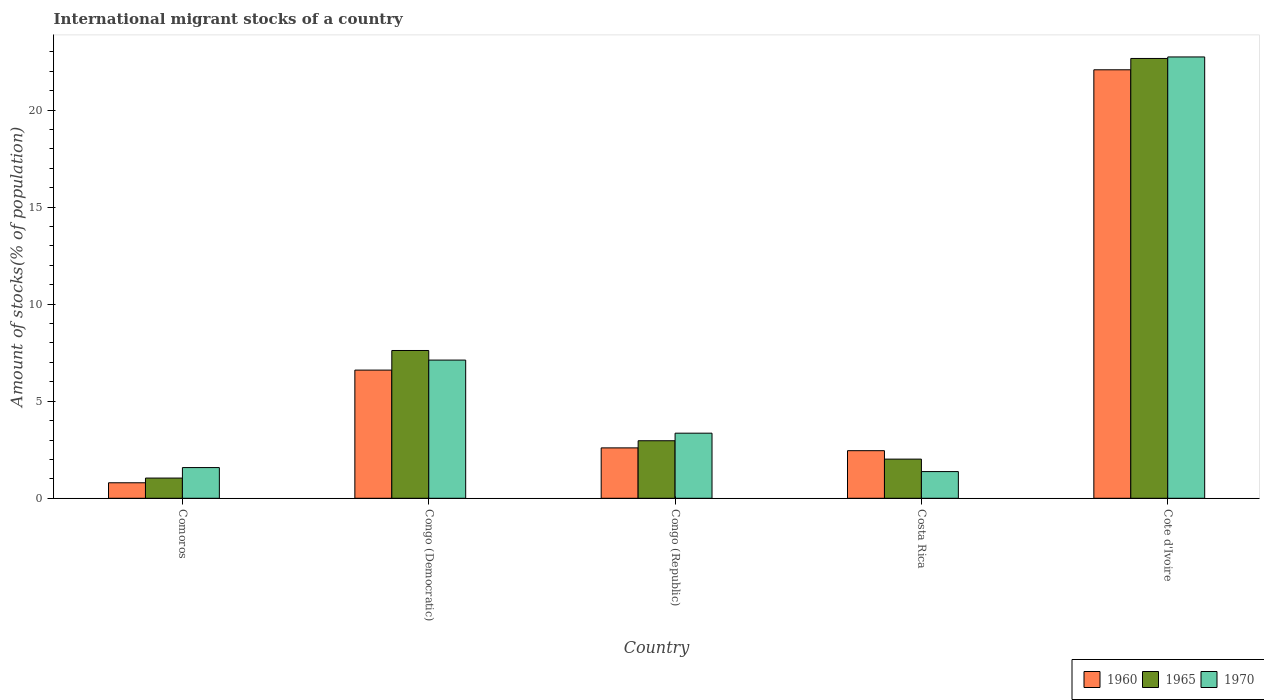How many different coloured bars are there?
Your answer should be compact. 3. Are the number of bars per tick equal to the number of legend labels?
Offer a very short reply. Yes. How many bars are there on the 2nd tick from the left?
Provide a succinct answer. 3. How many bars are there on the 2nd tick from the right?
Offer a terse response. 3. What is the label of the 2nd group of bars from the left?
Your answer should be compact. Congo (Democratic). What is the amount of stocks in in 1965 in Cote d'Ivoire?
Keep it short and to the point. 22.66. Across all countries, what is the maximum amount of stocks in in 1965?
Provide a succinct answer. 22.66. Across all countries, what is the minimum amount of stocks in in 1960?
Give a very brief answer. 0.8. In which country was the amount of stocks in in 1970 maximum?
Your answer should be very brief. Cote d'Ivoire. In which country was the amount of stocks in in 1970 minimum?
Ensure brevity in your answer.  Costa Rica. What is the total amount of stocks in in 1970 in the graph?
Your answer should be compact. 36.17. What is the difference between the amount of stocks in in 1965 in Congo (Democratic) and that in Cote d'Ivoire?
Your response must be concise. -15.04. What is the difference between the amount of stocks in in 1965 in Costa Rica and the amount of stocks in in 1960 in Cote d'Ivoire?
Make the answer very short. -20.06. What is the average amount of stocks in in 1970 per country?
Provide a short and direct response. 7.23. What is the difference between the amount of stocks in of/in 1970 and amount of stocks in of/in 1965 in Congo (Republic)?
Give a very brief answer. 0.39. In how many countries, is the amount of stocks in in 1960 greater than 16 %?
Offer a very short reply. 1. What is the ratio of the amount of stocks in in 1960 in Comoros to that in Congo (Republic)?
Keep it short and to the point. 0.31. Is the amount of stocks in in 1970 in Comoros less than that in Congo (Democratic)?
Keep it short and to the point. Yes. Is the difference between the amount of stocks in in 1970 in Comoros and Cote d'Ivoire greater than the difference between the amount of stocks in in 1965 in Comoros and Cote d'Ivoire?
Make the answer very short. Yes. What is the difference between the highest and the second highest amount of stocks in in 1970?
Provide a short and direct response. -19.38. What is the difference between the highest and the lowest amount of stocks in in 1970?
Make the answer very short. 21.36. In how many countries, is the amount of stocks in in 1970 greater than the average amount of stocks in in 1970 taken over all countries?
Make the answer very short. 1. Is the sum of the amount of stocks in in 1960 in Comoros and Congo (Republic) greater than the maximum amount of stocks in in 1970 across all countries?
Keep it short and to the point. No. How many countries are there in the graph?
Give a very brief answer. 5. What is the difference between two consecutive major ticks on the Y-axis?
Make the answer very short. 5. Are the values on the major ticks of Y-axis written in scientific E-notation?
Keep it short and to the point. No. Does the graph contain any zero values?
Offer a terse response. No. Where does the legend appear in the graph?
Your answer should be compact. Bottom right. How many legend labels are there?
Your answer should be very brief. 3. How are the legend labels stacked?
Offer a terse response. Horizontal. What is the title of the graph?
Keep it short and to the point. International migrant stocks of a country. What is the label or title of the X-axis?
Your response must be concise. Country. What is the label or title of the Y-axis?
Your response must be concise. Amount of stocks(% of population). What is the Amount of stocks(% of population) in 1960 in Comoros?
Your response must be concise. 0.8. What is the Amount of stocks(% of population) in 1965 in Comoros?
Your response must be concise. 1.04. What is the Amount of stocks(% of population) in 1970 in Comoros?
Give a very brief answer. 1.58. What is the Amount of stocks(% of population) of 1960 in Congo (Democratic)?
Give a very brief answer. 6.6. What is the Amount of stocks(% of population) in 1965 in Congo (Democratic)?
Make the answer very short. 7.61. What is the Amount of stocks(% of population) of 1970 in Congo (Democratic)?
Your response must be concise. 7.12. What is the Amount of stocks(% of population) in 1960 in Congo (Republic)?
Your answer should be very brief. 2.6. What is the Amount of stocks(% of population) in 1965 in Congo (Republic)?
Provide a short and direct response. 2.96. What is the Amount of stocks(% of population) of 1970 in Congo (Republic)?
Your answer should be compact. 3.35. What is the Amount of stocks(% of population) of 1960 in Costa Rica?
Make the answer very short. 2.45. What is the Amount of stocks(% of population) in 1965 in Costa Rica?
Ensure brevity in your answer.  2.02. What is the Amount of stocks(% of population) of 1970 in Costa Rica?
Provide a short and direct response. 1.38. What is the Amount of stocks(% of population) of 1960 in Cote d'Ivoire?
Give a very brief answer. 22.07. What is the Amount of stocks(% of population) of 1965 in Cote d'Ivoire?
Offer a terse response. 22.66. What is the Amount of stocks(% of population) in 1970 in Cote d'Ivoire?
Your answer should be compact. 22.74. Across all countries, what is the maximum Amount of stocks(% of population) in 1960?
Keep it short and to the point. 22.07. Across all countries, what is the maximum Amount of stocks(% of population) of 1965?
Provide a short and direct response. 22.66. Across all countries, what is the maximum Amount of stocks(% of population) in 1970?
Offer a terse response. 22.74. Across all countries, what is the minimum Amount of stocks(% of population) of 1960?
Give a very brief answer. 0.8. Across all countries, what is the minimum Amount of stocks(% of population) in 1965?
Your response must be concise. 1.04. Across all countries, what is the minimum Amount of stocks(% of population) in 1970?
Provide a short and direct response. 1.38. What is the total Amount of stocks(% of population) in 1960 in the graph?
Make the answer very short. 34.53. What is the total Amount of stocks(% of population) in 1965 in the graph?
Your response must be concise. 36.29. What is the total Amount of stocks(% of population) in 1970 in the graph?
Make the answer very short. 36.17. What is the difference between the Amount of stocks(% of population) in 1960 in Comoros and that in Congo (Democratic)?
Your answer should be compact. -5.81. What is the difference between the Amount of stocks(% of population) of 1965 in Comoros and that in Congo (Democratic)?
Provide a succinct answer. -6.57. What is the difference between the Amount of stocks(% of population) of 1970 in Comoros and that in Congo (Democratic)?
Offer a very short reply. -5.54. What is the difference between the Amount of stocks(% of population) of 1960 in Comoros and that in Congo (Republic)?
Your answer should be compact. -1.8. What is the difference between the Amount of stocks(% of population) of 1965 in Comoros and that in Congo (Republic)?
Provide a succinct answer. -1.92. What is the difference between the Amount of stocks(% of population) of 1970 in Comoros and that in Congo (Republic)?
Provide a short and direct response. -1.77. What is the difference between the Amount of stocks(% of population) of 1960 in Comoros and that in Costa Rica?
Your response must be concise. -1.65. What is the difference between the Amount of stocks(% of population) of 1965 in Comoros and that in Costa Rica?
Ensure brevity in your answer.  -0.98. What is the difference between the Amount of stocks(% of population) in 1970 in Comoros and that in Costa Rica?
Offer a terse response. 0.21. What is the difference between the Amount of stocks(% of population) of 1960 in Comoros and that in Cote d'Ivoire?
Offer a very short reply. -21.28. What is the difference between the Amount of stocks(% of population) in 1965 in Comoros and that in Cote d'Ivoire?
Ensure brevity in your answer.  -21.62. What is the difference between the Amount of stocks(% of population) in 1970 in Comoros and that in Cote d'Ivoire?
Make the answer very short. -21.15. What is the difference between the Amount of stocks(% of population) in 1960 in Congo (Democratic) and that in Congo (Republic)?
Make the answer very short. 4.01. What is the difference between the Amount of stocks(% of population) of 1965 in Congo (Democratic) and that in Congo (Republic)?
Offer a very short reply. 4.65. What is the difference between the Amount of stocks(% of population) in 1970 in Congo (Democratic) and that in Congo (Republic)?
Ensure brevity in your answer.  3.77. What is the difference between the Amount of stocks(% of population) of 1960 in Congo (Democratic) and that in Costa Rica?
Your answer should be compact. 4.15. What is the difference between the Amount of stocks(% of population) of 1965 in Congo (Democratic) and that in Costa Rica?
Provide a succinct answer. 5.6. What is the difference between the Amount of stocks(% of population) of 1970 in Congo (Democratic) and that in Costa Rica?
Offer a terse response. 5.74. What is the difference between the Amount of stocks(% of population) in 1960 in Congo (Democratic) and that in Cote d'Ivoire?
Offer a terse response. -15.47. What is the difference between the Amount of stocks(% of population) of 1965 in Congo (Democratic) and that in Cote d'Ivoire?
Make the answer very short. -15.04. What is the difference between the Amount of stocks(% of population) in 1970 in Congo (Democratic) and that in Cote d'Ivoire?
Your answer should be compact. -15.62. What is the difference between the Amount of stocks(% of population) in 1960 in Congo (Republic) and that in Costa Rica?
Offer a terse response. 0.14. What is the difference between the Amount of stocks(% of population) in 1965 in Congo (Republic) and that in Costa Rica?
Keep it short and to the point. 0.95. What is the difference between the Amount of stocks(% of population) of 1970 in Congo (Republic) and that in Costa Rica?
Provide a short and direct response. 1.98. What is the difference between the Amount of stocks(% of population) of 1960 in Congo (Republic) and that in Cote d'Ivoire?
Provide a short and direct response. -19.48. What is the difference between the Amount of stocks(% of population) of 1965 in Congo (Republic) and that in Cote d'Ivoire?
Ensure brevity in your answer.  -19.69. What is the difference between the Amount of stocks(% of population) in 1970 in Congo (Republic) and that in Cote d'Ivoire?
Your answer should be very brief. -19.38. What is the difference between the Amount of stocks(% of population) in 1960 in Costa Rica and that in Cote d'Ivoire?
Give a very brief answer. -19.62. What is the difference between the Amount of stocks(% of population) in 1965 in Costa Rica and that in Cote d'Ivoire?
Your answer should be compact. -20.64. What is the difference between the Amount of stocks(% of population) of 1970 in Costa Rica and that in Cote d'Ivoire?
Ensure brevity in your answer.  -21.36. What is the difference between the Amount of stocks(% of population) in 1960 in Comoros and the Amount of stocks(% of population) in 1965 in Congo (Democratic)?
Keep it short and to the point. -6.82. What is the difference between the Amount of stocks(% of population) of 1960 in Comoros and the Amount of stocks(% of population) of 1970 in Congo (Democratic)?
Provide a short and direct response. -6.32. What is the difference between the Amount of stocks(% of population) of 1965 in Comoros and the Amount of stocks(% of population) of 1970 in Congo (Democratic)?
Give a very brief answer. -6.08. What is the difference between the Amount of stocks(% of population) of 1960 in Comoros and the Amount of stocks(% of population) of 1965 in Congo (Republic)?
Provide a succinct answer. -2.17. What is the difference between the Amount of stocks(% of population) of 1960 in Comoros and the Amount of stocks(% of population) of 1970 in Congo (Republic)?
Offer a very short reply. -2.55. What is the difference between the Amount of stocks(% of population) of 1965 in Comoros and the Amount of stocks(% of population) of 1970 in Congo (Republic)?
Offer a very short reply. -2.31. What is the difference between the Amount of stocks(% of population) of 1960 in Comoros and the Amount of stocks(% of population) of 1965 in Costa Rica?
Ensure brevity in your answer.  -1.22. What is the difference between the Amount of stocks(% of population) in 1960 in Comoros and the Amount of stocks(% of population) in 1970 in Costa Rica?
Give a very brief answer. -0.58. What is the difference between the Amount of stocks(% of population) of 1965 in Comoros and the Amount of stocks(% of population) of 1970 in Costa Rica?
Ensure brevity in your answer.  -0.33. What is the difference between the Amount of stocks(% of population) in 1960 in Comoros and the Amount of stocks(% of population) in 1965 in Cote d'Ivoire?
Your answer should be compact. -21.86. What is the difference between the Amount of stocks(% of population) in 1960 in Comoros and the Amount of stocks(% of population) in 1970 in Cote d'Ivoire?
Keep it short and to the point. -21.94. What is the difference between the Amount of stocks(% of population) of 1965 in Comoros and the Amount of stocks(% of population) of 1970 in Cote d'Ivoire?
Your answer should be compact. -21.7. What is the difference between the Amount of stocks(% of population) of 1960 in Congo (Democratic) and the Amount of stocks(% of population) of 1965 in Congo (Republic)?
Provide a short and direct response. 3.64. What is the difference between the Amount of stocks(% of population) of 1960 in Congo (Democratic) and the Amount of stocks(% of population) of 1970 in Congo (Republic)?
Keep it short and to the point. 3.25. What is the difference between the Amount of stocks(% of population) of 1965 in Congo (Democratic) and the Amount of stocks(% of population) of 1970 in Congo (Republic)?
Keep it short and to the point. 4.26. What is the difference between the Amount of stocks(% of population) of 1960 in Congo (Democratic) and the Amount of stocks(% of population) of 1965 in Costa Rica?
Give a very brief answer. 4.59. What is the difference between the Amount of stocks(% of population) of 1960 in Congo (Democratic) and the Amount of stocks(% of population) of 1970 in Costa Rica?
Give a very brief answer. 5.23. What is the difference between the Amount of stocks(% of population) in 1965 in Congo (Democratic) and the Amount of stocks(% of population) in 1970 in Costa Rica?
Keep it short and to the point. 6.24. What is the difference between the Amount of stocks(% of population) of 1960 in Congo (Democratic) and the Amount of stocks(% of population) of 1965 in Cote d'Ivoire?
Provide a short and direct response. -16.05. What is the difference between the Amount of stocks(% of population) of 1960 in Congo (Democratic) and the Amount of stocks(% of population) of 1970 in Cote d'Ivoire?
Make the answer very short. -16.13. What is the difference between the Amount of stocks(% of population) of 1965 in Congo (Democratic) and the Amount of stocks(% of population) of 1970 in Cote d'Ivoire?
Make the answer very short. -15.12. What is the difference between the Amount of stocks(% of population) in 1960 in Congo (Republic) and the Amount of stocks(% of population) in 1965 in Costa Rica?
Offer a terse response. 0.58. What is the difference between the Amount of stocks(% of population) of 1960 in Congo (Republic) and the Amount of stocks(% of population) of 1970 in Costa Rica?
Keep it short and to the point. 1.22. What is the difference between the Amount of stocks(% of population) of 1965 in Congo (Republic) and the Amount of stocks(% of population) of 1970 in Costa Rica?
Provide a succinct answer. 1.59. What is the difference between the Amount of stocks(% of population) of 1960 in Congo (Republic) and the Amount of stocks(% of population) of 1965 in Cote d'Ivoire?
Your answer should be compact. -20.06. What is the difference between the Amount of stocks(% of population) in 1960 in Congo (Republic) and the Amount of stocks(% of population) in 1970 in Cote d'Ivoire?
Your answer should be very brief. -20.14. What is the difference between the Amount of stocks(% of population) of 1965 in Congo (Republic) and the Amount of stocks(% of population) of 1970 in Cote d'Ivoire?
Provide a succinct answer. -19.77. What is the difference between the Amount of stocks(% of population) of 1960 in Costa Rica and the Amount of stocks(% of population) of 1965 in Cote d'Ivoire?
Ensure brevity in your answer.  -20.21. What is the difference between the Amount of stocks(% of population) in 1960 in Costa Rica and the Amount of stocks(% of population) in 1970 in Cote d'Ivoire?
Your answer should be compact. -20.28. What is the difference between the Amount of stocks(% of population) of 1965 in Costa Rica and the Amount of stocks(% of population) of 1970 in Cote d'Ivoire?
Offer a very short reply. -20.72. What is the average Amount of stocks(% of population) in 1960 per country?
Provide a short and direct response. 6.91. What is the average Amount of stocks(% of population) of 1965 per country?
Offer a very short reply. 7.26. What is the average Amount of stocks(% of population) of 1970 per country?
Ensure brevity in your answer.  7.23. What is the difference between the Amount of stocks(% of population) of 1960 and Amount of stocks(% of population) of 1965 in Comoros?
Ensure brevity in your answer.  -0.24. What is the difference between the Amount of stocks(% of population) of 1960 and Amount of stocks(% of population) of 1970 in Comoros?
Provide a short and direct response. -0.78. What is the difference between the Amount of stocks(% of population) of 1965 and Amount of stocks(% of population) of 1970 in Comoros?
Keep it short and to the point. -0.54. What is the difference between the Amount of stocks(% of population) in 1960 and Amount of stocks(% of population) in 1965 in Congo (Democratic)?
Make the answer very short. -1.01. What is the difference between the Amount of stocks(% of population) in 1960 and Amount of stocks(% of population) in 1970 in Congo (Democratic)?
Make the answer very short. -0.52. What is the difference between the Amount of stocks(% of population) in 1965 and Amount of stocks(% of population) in 1970 in Congo (Democratic)?
Make the answer very short. 0.49. What is the difference between the Amount of stocks(% of population) in 1960 and Amount of stocks(% of population) in 1965 in Congo (Republic)?
Ensure brevity in your answer.  -0.37. What is the difference between the Amount of stocks(% of population) in 1960 and Amount of stocks(% of population) in 1970 in Congo (Republic)?
Provide a short and direct response. -0.76. What is the difference between the Amount of stocks(% of population) of 1965 and Amount of stocks(% of population) of 1970 in Congo (Republic)?
Offer a terse response. -0.39. What is the difference between the Amount of stocks(% of population) in 1960 and Amount of stocks(% of population) in 1965 in Costa Rica?
Your answer should be compact. 0.43. What is the difference between the Amount of stocks(% of population) in 1960 and Amount of stocks(% of population) in 1970 in Costa Rica?
Give a very brief answer. 1.08. What is the difference between the Amount of stocks(% of population) of 1965 and Amount of stocks(% of population) of 1970 in Costa Rica?
Provide a short and direct response. 0.64. What is the difference between the Amount of stocks(% of population) of 1960 and Amount of stocks(% of population) of 1965 in Cote d'Ivoire?
Your answer should be very brief. -0.58. What is the difference between the Amount of stocks(% of population) in 1960 and Amount of stocks(% of population) in 1970 in Cote d'Ivoire?
Your response must be concise. -0.66. What is the difference between the Amount of stocks(% of population) in 1965 and Amount of stocks(% of population) in 1970 in Cote d'Ivoire?
Keep it short and to the point. -0.08. What is the ratio of the Amount of stocks(% of population) of 1960 in Comoros to that in Congo (Democratic)?
Give a very brief answer. 0.12. What is the ratio of the Amount of stocks(% of population) in 1965 in Comoros to that in Congo (Democratic)?
Offer a terse response. 0.14. What is the ratio of the Amount of stocks(% of population) in 1970 in Comoros to that in Congo (Democratic)?
Provide a short and direct response. 0.22. What is the ratio of the Amount of stocks(% of population) of 1960 in Comoros to that in Congo (Republic)?
Ensure brevity in your answer.  0.31. What is the ratio of the Amount of stocks(% of population) in 1965 in Comoros to that in Congo (Republic)?
Provide a short and direct response. 0.35. What is the ratio of the Amount of stocks(% of population) of 1970 in Comoros to that in Congo (Republic)?
Your answer should be very brief. 0.47. What is the ratio of the Amount of stocks(% of population) in 1960 in Comoros to that in Costa Rica?
Offer a very short reply. 0.33. What is the ratio of the Amount of stocks(% of population) in 1965 in Comoros to that in Costa Rica?
Your answer should be compact. 0.52. What is the ratio of the Amount of stocks(% of population) in 1970 in Comoros to that in Costa Rica?
Your response must be concise. 1.15. What is the ratio of the Amount of stocks(% of population) in 1960 in Comoros to that in Cote d'Ivoire?
Your answer should be very brief. 0.04. What is the ratio of the Amount of stocks(% of population) of 1965 in Comoros to that in Cote d'Ivoire?
Make the answer very short. 0.05. What is the ratio of the Amount of stocks(% of population) in 1970 in Comoros to that in Cote d'Ivoire?
Your answer should be compact. 0.07. What is the ratio of the Amount of stocks(% of population) of 1960 in Congo (Democratic) to that in Congo (Republic)?
Ensure brevity in your answer.  2.54. What is the ratio of the Amount of stocks(% of population) of 1965 in Congo (Democratic) to that in Congo (Republic)?
Offer a terse response. 2.57. What is the ratio of the Amount of stocks(% of population) in 1970 in Congo (Democratic) to that in Congo (Republic)?
Offer a terse response. 2.12. What is the ratio of the Amount of stocks(% of population) in 1960 in Congo (Democratic) to that in Costa Rica?
Provide a short and direct response. 2.69. What is the ratio of the Amount of stocks(% of population) of 1965 in Congo (Democratic) to that in Costa Rica?
Give a very brief answer. 3.77. What is the ratio of the Amount of stocks(% of population) of 1970 in Congo (Democratic) to that in Costa Rica?
Ensure brevity in your answer.  5.18. What is the ratio of the Amount of stocks(% of population) of 1960 in Congo (Democratic) to that in Cote d'Ivoire?
Provide a short and direct response. 0.3. What is the ratio of the Amount of stocks(% of population) of 1965 in Congo (Democratic) to that in Cote d'Ivoire?
Offer a very short reply. 0.34. What is the ratio of the Amount of stocks(% of population) in 1970 in Congo (Democratic) to that in Cote d'Ivoire?
Offer a very short reply. 0.31. What is the ratio of the Amount of stocks(% of population) in 1960 in Congo (Republic) to that in Costa Rica?
Provide a succinct answer. 1.06. What is the ratio of the Amount of stocks(% of population) in 1965 in Congo (Republic) to that in Costa Rica?
Your answer should be very brief. 1.47. What is the ratio of the Amount of stocks(% of population) in 1970 in Congo (Republic) to that in Costa Rica?
Ensure brevity in your answer.  2.44. What is the ratio of the Amount of stocks(% of population) of 1960 in Congo (Republic) to that in Cote d'Ivoire?
Provide a succinct answer. 0.12. What is the ratio of the Amount of stocks(% of population) of 1965 in Congo (Republic) to that in Cote d'Ivoire?
Offer a very short reply. 0.13. What is the ratio of the Amount of stocks(% of population) in 1970 in Congo (Republic) to that in Cote d'Ivoire?
Make the answer very short. 0.15. What is the ratio of the Amount of stocks(% of population) in 1965 in Costa Rica to that in Cote d'Ivoire?
Ensure brevity in your answer.  0.09. What is the ratio of the Amount of stocks(% of population) in 1970 in Costa Rica to that in Cote d'Ivoire?
Provide a short and direct response. 0.06. What is the difference between the highest and the second highest Amount of stocks(% of population) of 1960?
Give a very brief answer. 15.47. What is the difference between the highest and the second highest Amount of stocks(% of population) of 1965?
Your response must be concise. 15.04. What is the difference between the highest and the second highest Amount of stocks(% of population) in 1970?
Make the answer very short. 15.62. What is the difference between the highest and the lowest Amount of stocks(% of population) of 1960?
Ensure brevity in your answer.  21.28. What is the difference between the highest and the lowest Amount of stocks(% of population) of 1965?
Offer a very short reply. 21.62. What is the difference between the highest and the lowest Amount of stocks(% of population) in 1970?
Ensure brevity in your answer.  21.36. 